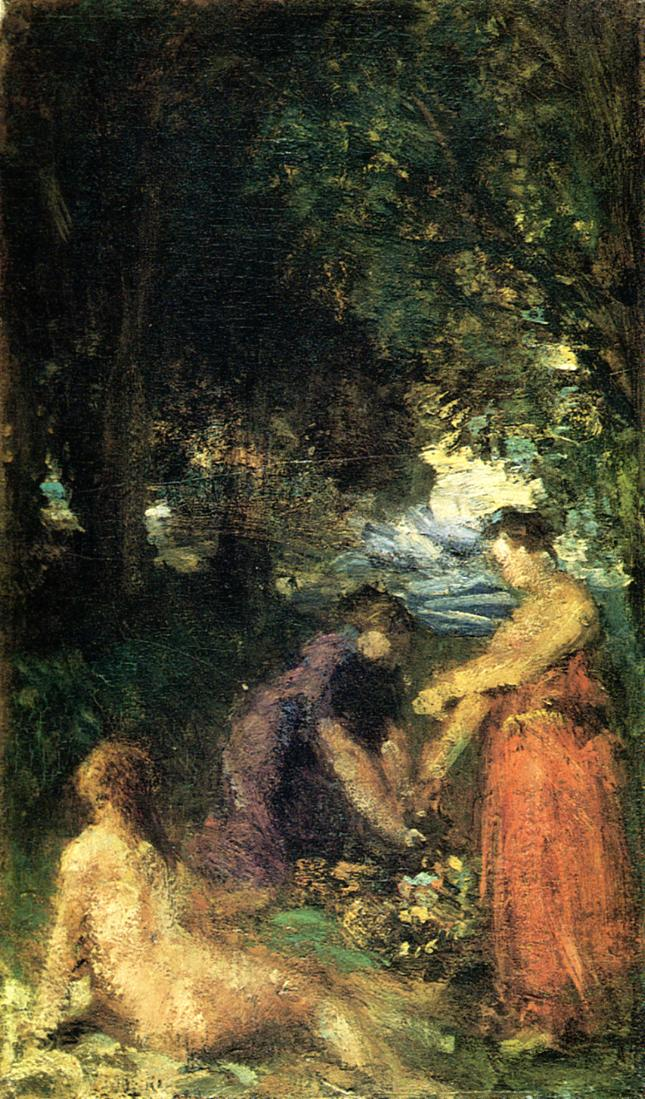Can you describe the emotions this painting might evoke in a viewer? This painting may stir a sense of quietude and nostalgia, reconnecting the viewer with the serene and unspoiled charm of nature. The blurry outlines and interplay of light and darkness could evoke a sense of mystery and tranquility, inviting contemplation. What might be the significance of the people in the painting? The presence of people in the painting may symbolize the harmonious relationship between mankind and nature. It could also indicate a moment of leisurely respite, a scene capturing the everyday beauty in the lives of individuals from the period. 